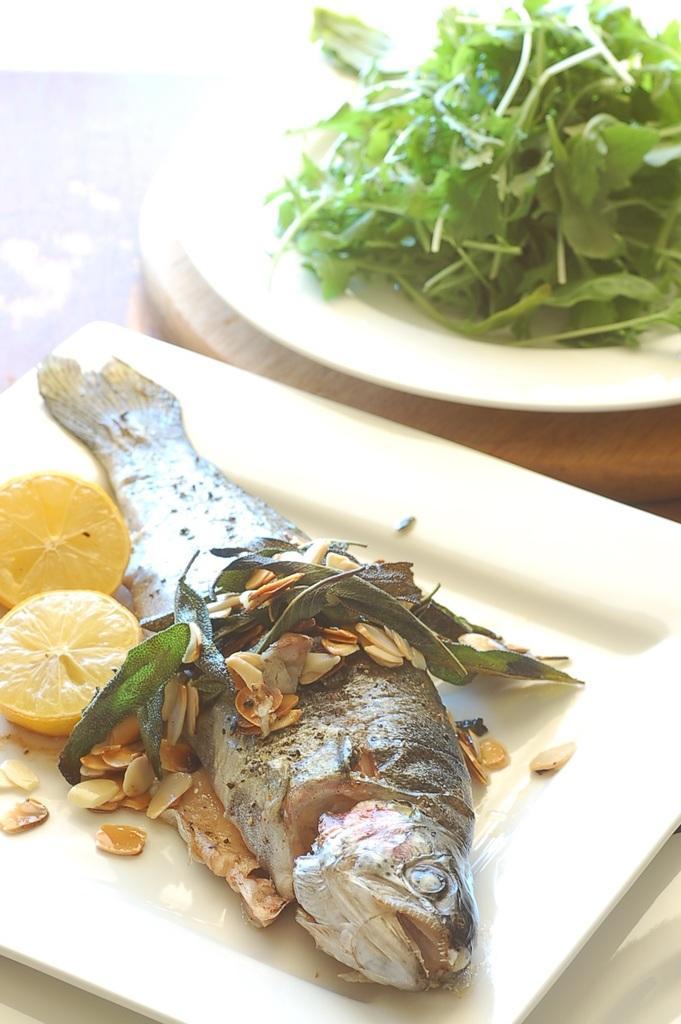Describe this image in one or two sentences. In this picture I can see the fried fish, lemon, leaves and other objects in a white plate. In the top right corner I can see the mint which is kept on a plate. This plates are kept on the table. 